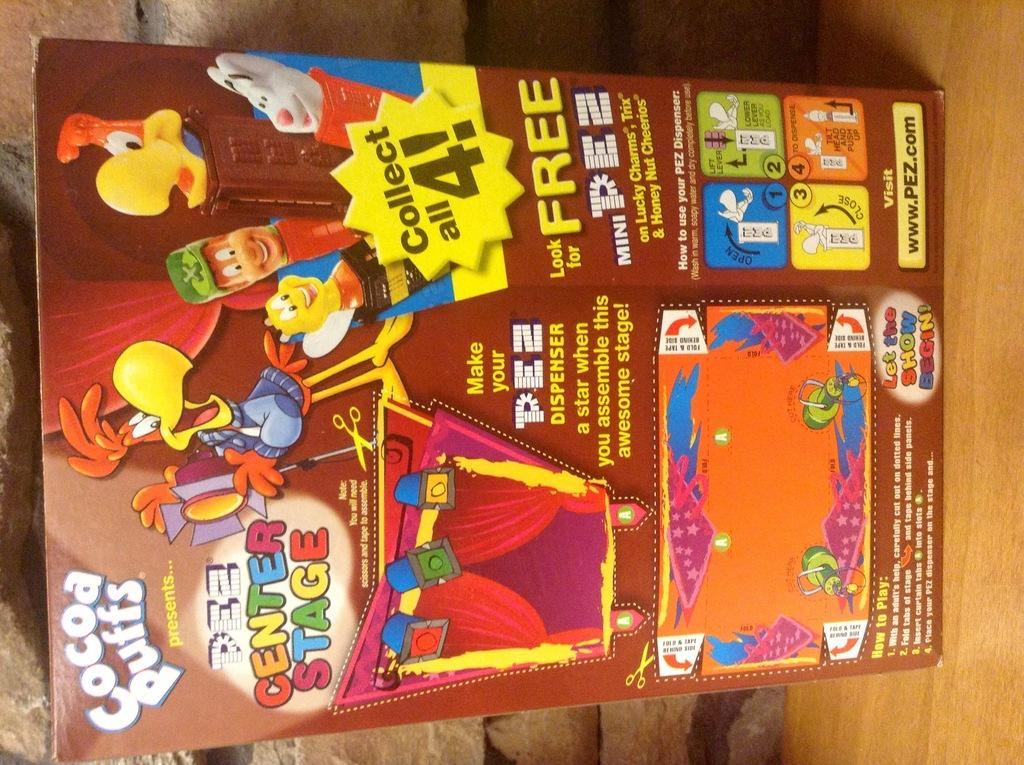What object is located on the right side of the image? There is a table on the right side of the image. What is placed on the table in the image? There is a paper on the table. What can be seen behind the paper in the image? There is a wall behind the paper. What type of amusement can be seen on the table in the image? There is no amusement present on the table in the image; it features a paper on a table with a wall behind it. What color is the copper dress in the image? There is no copper dress present in the image. 